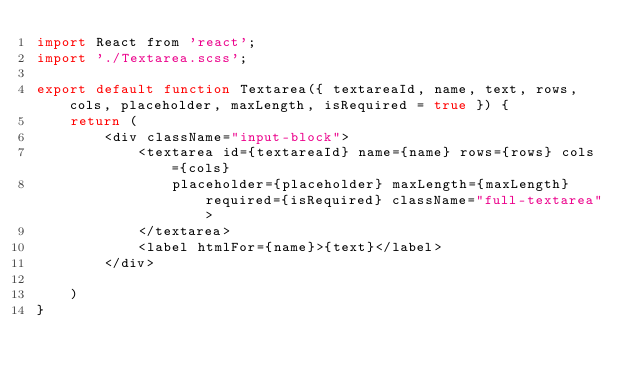<code> <loc_0><loc_0><loc_500><loc_500><_JavaScript_>import React from 'react';
import './Textarea.scss';

export default function Textarea({ textareaId, name, text, rows, cols, placeholder, maxLength, isRequired = true }) {
    return (
        <div className="input-block">
            <textarea id={textareaId} name={name} rows={rows} cols={cols}
                placeholder={placeholder} maxLength={maxLength} required={isRequired} className="full-textarea">
            </textarea>
            <label htmlFor={name}>{text}</label>
        </div>

    )
}</code> 